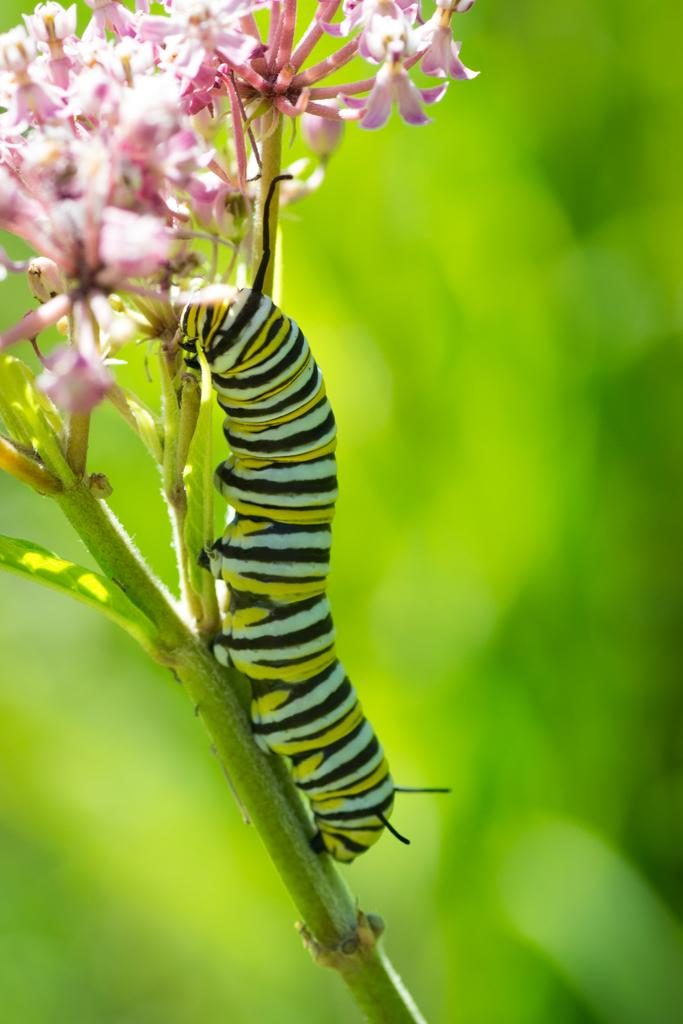What is present in the picture that is small and has multiple legs? There is an insect in the picture. What is the insect doing in the picture? The insect is moving on the stem of a plant. What other elements can be seen in the picture besides the insect? There are flowers and buds in the picture. What type of button can be seen on the verse in the picture? There is no button or verse present in the picture; it features an insect on a plant with flowers and buds. 